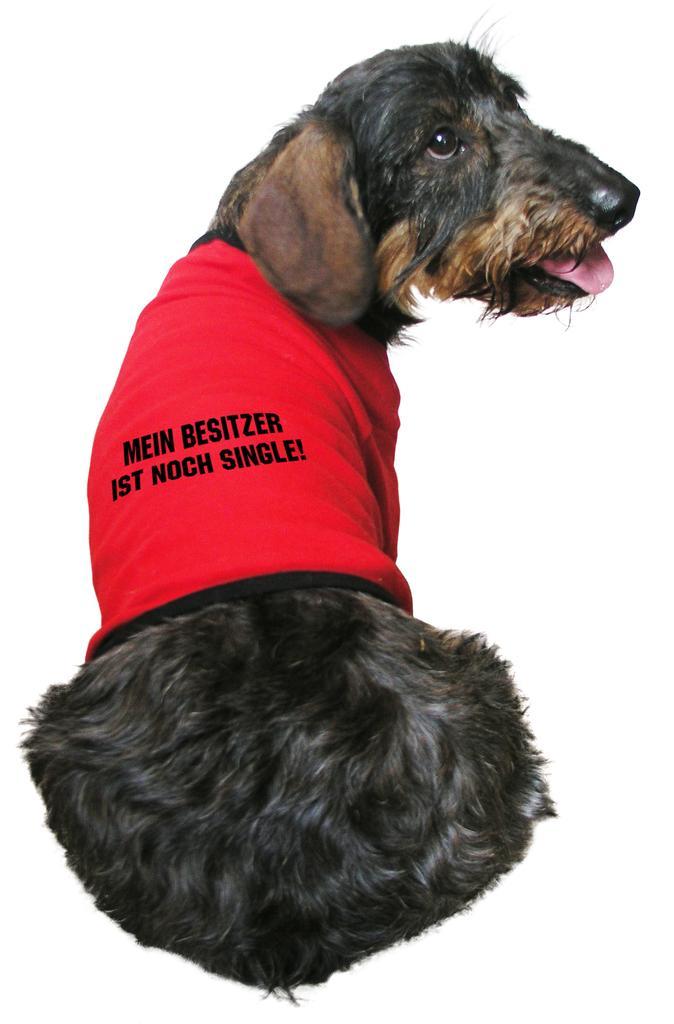Describe this image in one or two sentences. In the foreground of this image, there is a black color dog wearing a red color T shirt. 